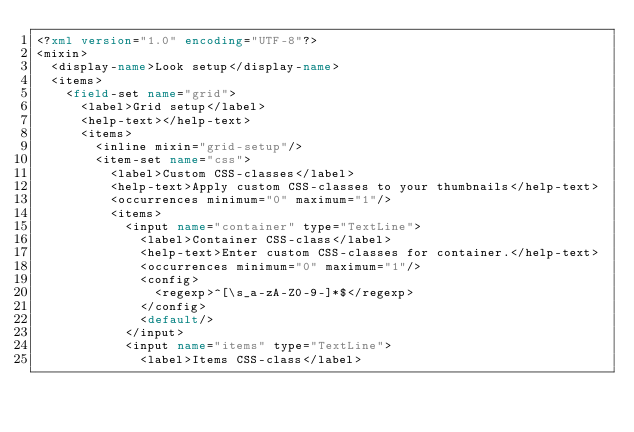Convert code to text. <code><loc_0><loc_0><loc_500><loc_500><_XML_><?xml version="1.0" encoding="UTF-8"?>
<mixin>
	<display-name>Look setup</display-name>
	<items>
		<field-set name="grid">
			<label>Grid setup</label>
			<help-text></help-text>
			<items>
				<inline mixin="grid-setup"/>
				<item-set name="css">
					<label>Custom CSS-classes</label>
					<help-text>Apply custom CSS-classes to your thumbnails</help-text>
					<occurrences minimum="0" maximum="1"/>
					<items>
						<input name="container" type="TextLine">
							<label>Container CSS-class</label>
							<help-text>Enter custom CSS-classes for container.</help-text>
							<occurrences minimum="0" maximum="1"/>
							<config>
								<regexp>^[\s_a-zA-Z0-9-]*$</regexp>
							</config>
							<default/>
						</input>
						<input name="items" type="TextLine">
							<label>Items CSS-class</label></code> 